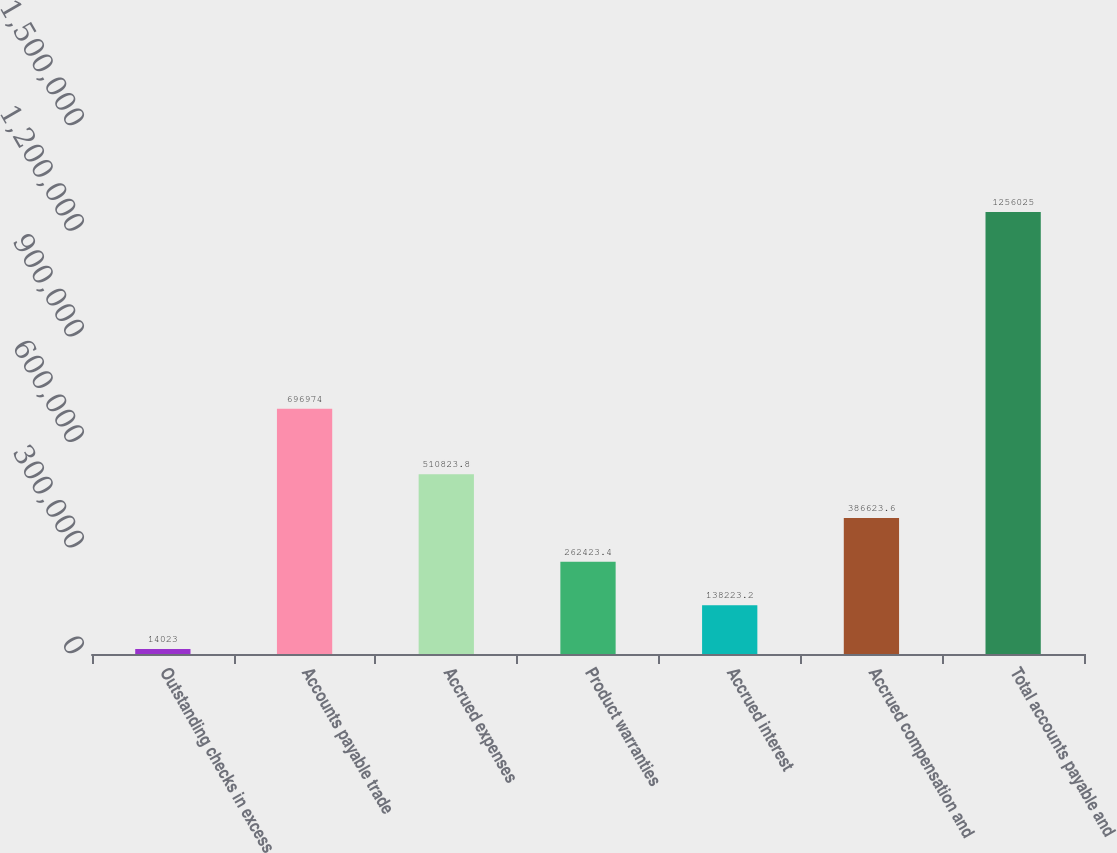<chart> <loc_0><loc_0><loc_500><loc_500><bar_chart><fcel>Outstanding checks in excess<fcel>Accounts payable trade<fcel>Accrued expenses<fcel>Product warranties<fcel>Accrued interest<fcel>Accrued compensation and<fcel>Total accounts payable and<nl><fcel>14023<fcel>696974<fcel>510824<fcel>262423<fcel>138223<fcel>386624<fcel>1.25602e+06<nl></chart> 